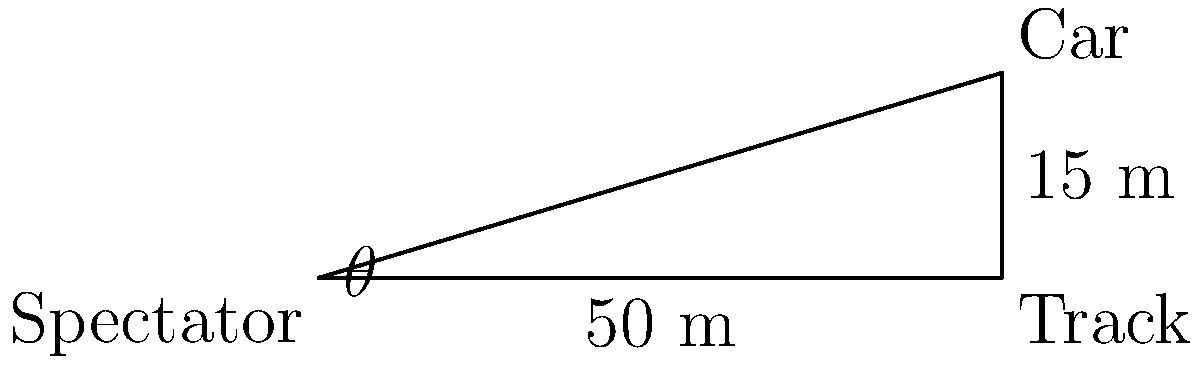At the Daytona 500, a spectator is seated 50 meters from the edge of the track. If a car is currently 15 meters above the track surface (due to the steep banking), what is the angle of elevation from the spectator's position to the car? To solve this problem, we'll use trigonometry, specifically the tangent function. Let's break it down step-by-step:

1) We have a right triangle with:
   - The base (adjacent side) = 50 meters (distance from spectator to track)
   - The height (opposite side) = 15 meters (height of car above track)
   - The angle of elevation ($\theta$) is what we're looking for

2) The tangent of an angle in a right triangle is the ratio of the opposite side to the adjacent side:

   $\tan(\theta) = \frac{\text{opposite}}{\text{adjacent}} = \frac{\text{height}}{\text{base}}$

3) Plugging in our values:

   $\tan(\theta) = \frac{15}{50} = 0.3$

4) To find $\theta$, we need to use the inverse tangent (arctan or $\tan^{-1}$):

   $\theta = \tan^{-1}(0.3)$

5) Using a calculator or trigonometric tables:

   $\theta \approx 16.70^\circ$

6) Rounding to the nearest degree:

   $\theta \approx 17^\circ$

Thus, the angle of elevation from the spectator's position to the car is approximately 17 degrees.
Answer: $17^\circ$ 